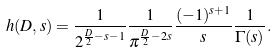Convert formula to latex. <formula><loc_0><loc_0><loc_500><loc_500>h ( D , s ) = \frac { 1 } { 2 ^ { \frac { D } { 2 } - s - 1 } } \frac { 1 } { \pi ^ { \frac { D } { 2 } - 2 s } } \frac { ( - 1 ) ^ { s + 1 } } { s } \frac { 1 } { \Gamma ( s ) } .</formula> 